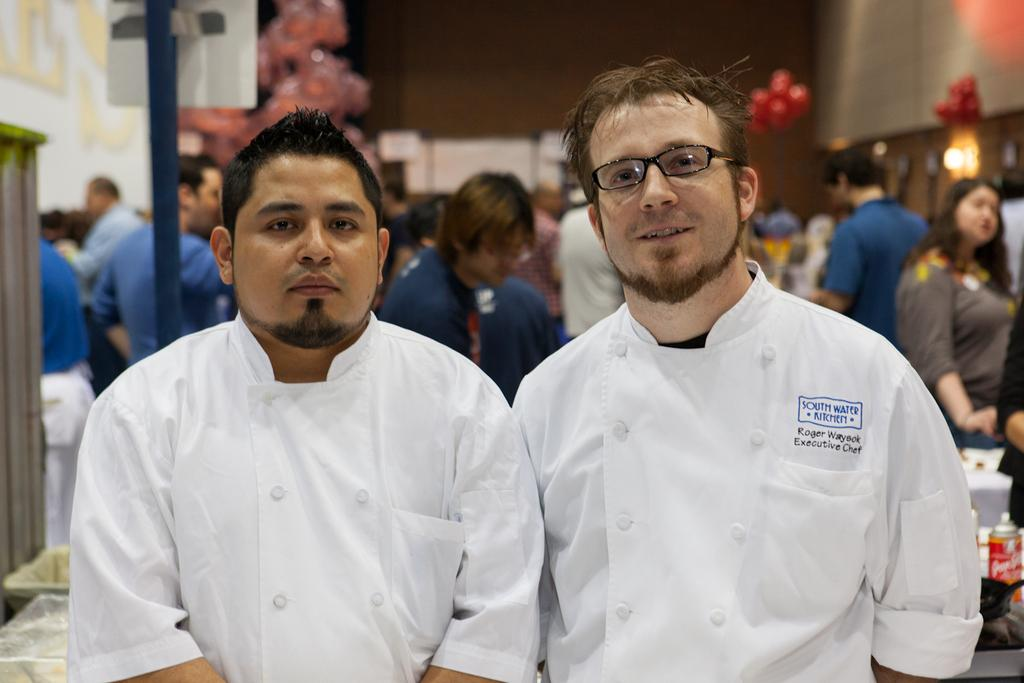How many people are in the group shown in the image? There is a group of people in the image, but the exact number is not specified. What is the person wearing in the group? One person in the group is wearing a white dress. What can be seen in the background of the image? There are lights visible in the background of the image. What type of decoration is present in the image? There are red balloons in the image. What is the chance of finding a ripe berry in the image? There is no mention of berries in the image, so it is impossible to determine the chance of finding a ripe one. What type of pump is visible in the image? There is no pump present in the image. 